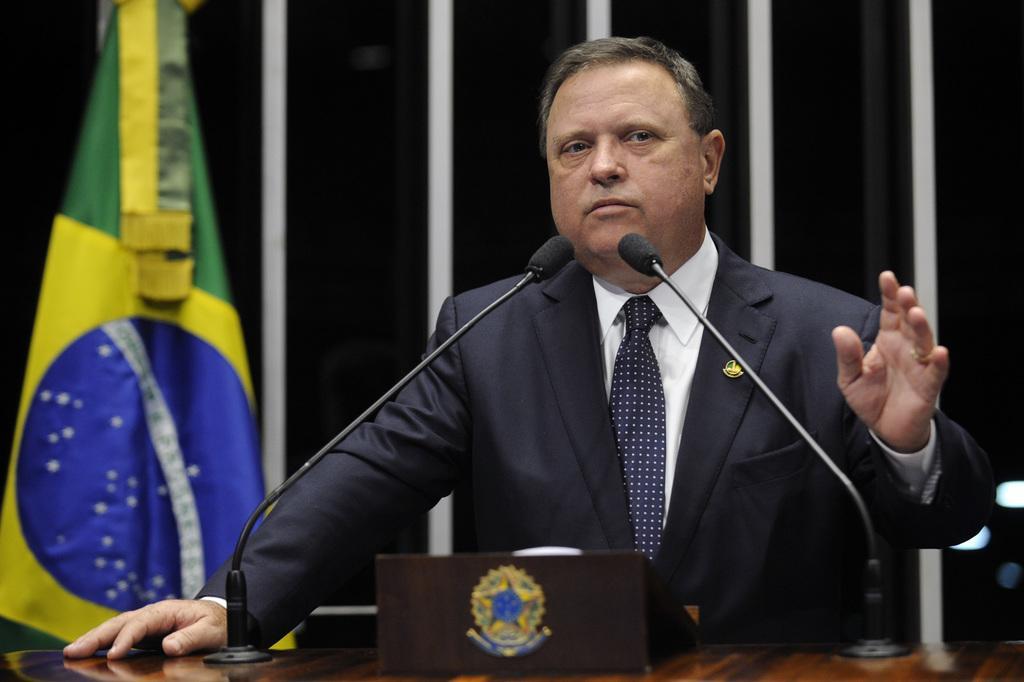How would you summarize this image in a sentence or two? In the center of the image we can see a man standing before him there is a podium and there are mics placed on the podium. In the background there is a flag and a curtain. 